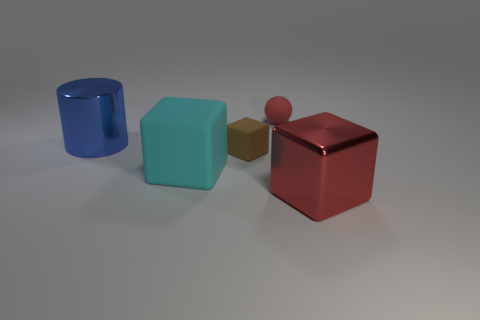Add 3 tiny matte objects. How many objects exist? 8 Subtract all balls. How many objects are left? 4 Subtract 1 blue cylinders. How many objects are left? 4 Subtract all large rubber cubes. Subtract all cubes. How many objects are left? 1 Add 2 tiny matte balls. How many tiny matte balls are left? 3 Add 3 large shiny cubes. How many large shiny cubes exist? 4 